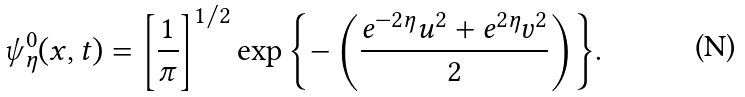Convert formula to latex. <formula><loc_0><loc_0><loc_500><loc_500>\psi _ { \eta } ^ { 0 } ( x , t ) = \left [ \frac { 1 } { \pi } \right ] ^ { 1 / 2 } \exp { \left \{ - \left ( \frac { e ^ { - 2 \eta } u ^ { 2 } + e ^ { 2 \eta } v ^ { 2 } } { 2 } \right ) \right \} } .</formula> 